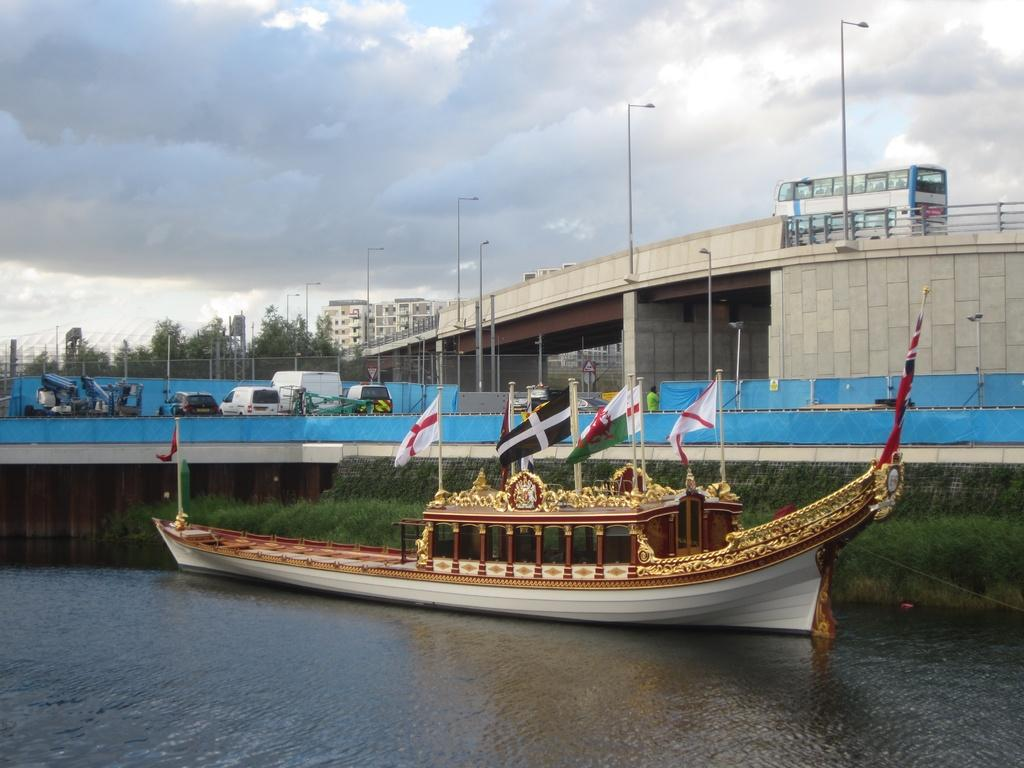What is the main subject of the image? The main subject of the image is a boat on the water. What else can be seen in the image besides the boat? Flags, vehicles, fences, poles, buildings, trees, and a bus on a bridge are visible in the image. What is the condition of the sky in the image? The sky with clouds is visible in the background of the image. Where is the bucket located in the image? There is no bucket present in the image. What type of van can be seen in the image? There is no van present in the image. 